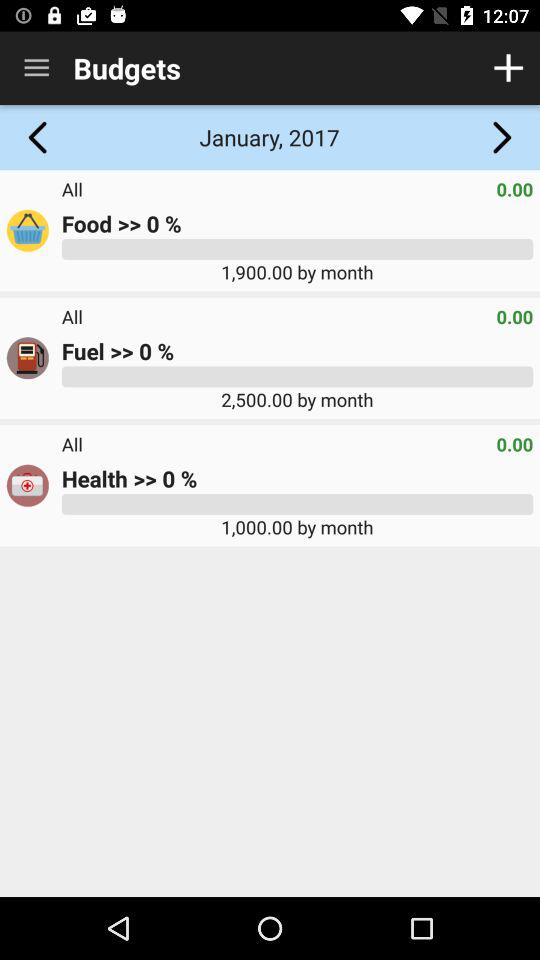Which month's budget is available on the screen? The budget of January is available on the screen. 